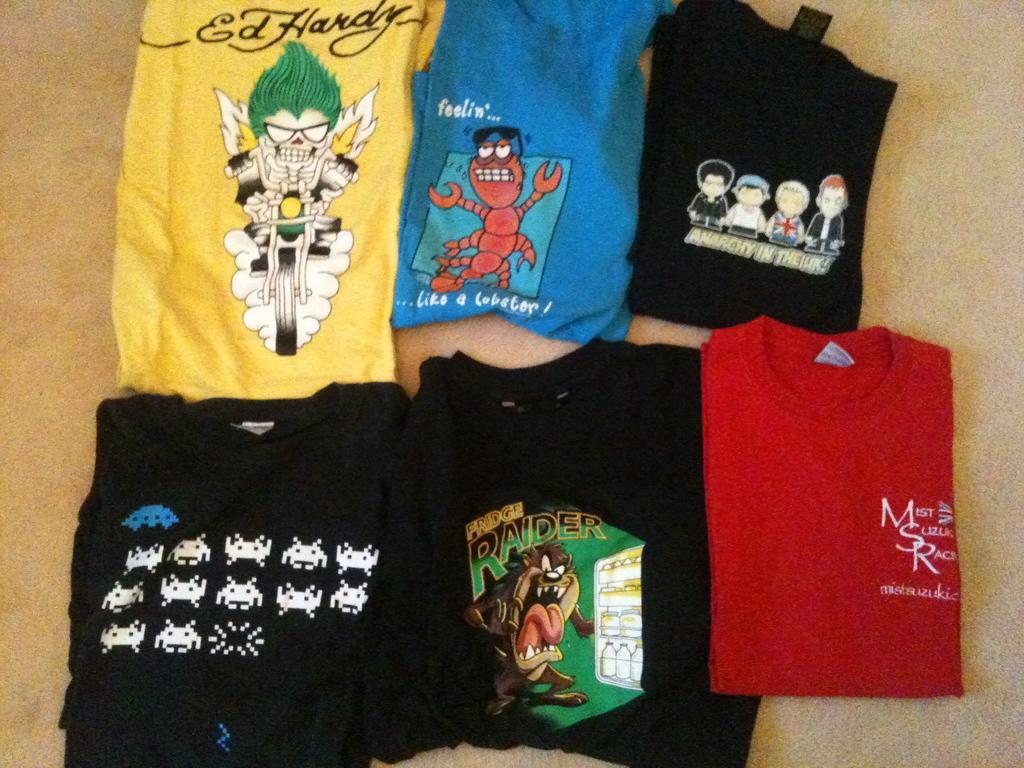Describe this image in one or two sentences. The picture consists of t-shirts of different colors. On the t-shirts there are different images. 